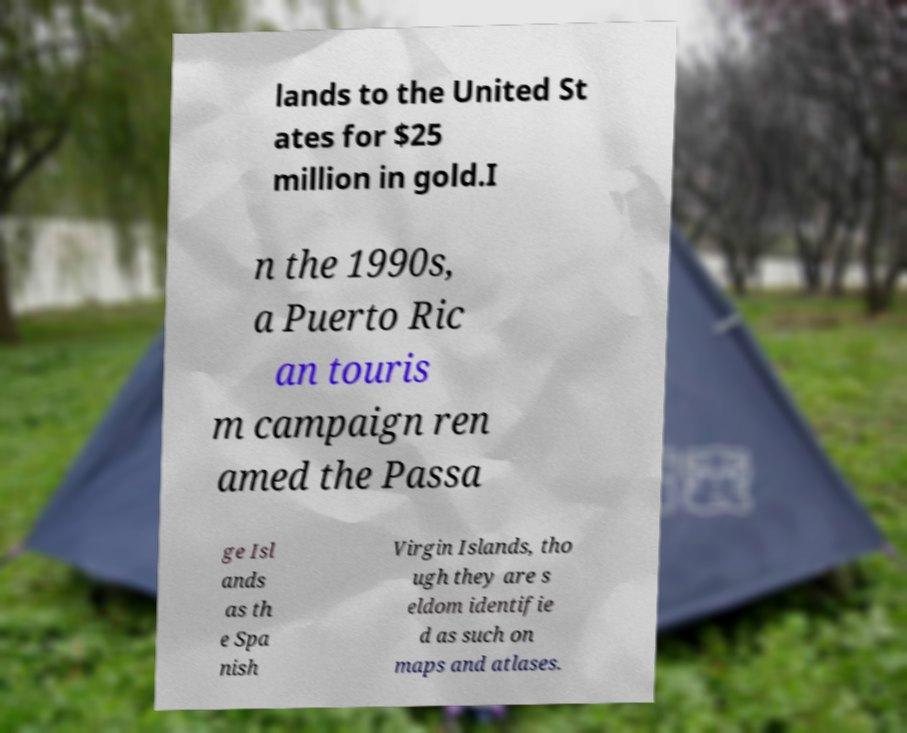Could you extract and type out the text from this image? lands to the United St ates for $25 million in gold.I n the 1990s, a Puerto Ric an touris m campaign ren amed the Passa ge Isl ands as th e Spa nish Virgin Islands, tho ugh they are s eldom identifie d as such on maps and atlases. 